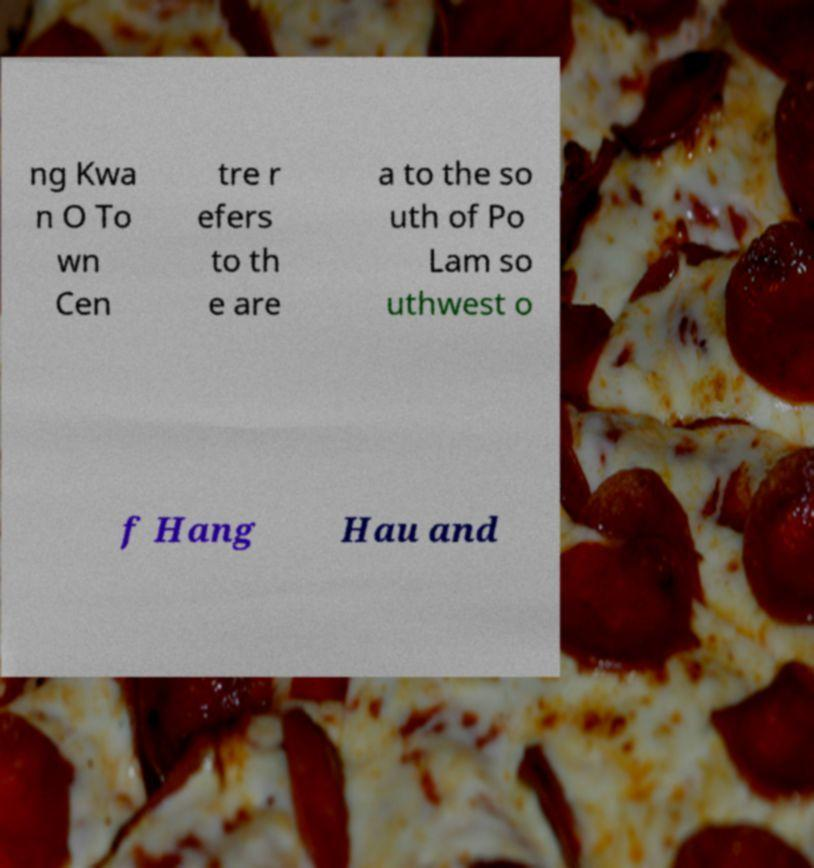Could you assist in decoding the text presented in this image and type it out clearly? ng Kwa n O To wn Cen tre r efers to th e are a to the so uth of Po Lam so uthwest o f Hang Hau and 